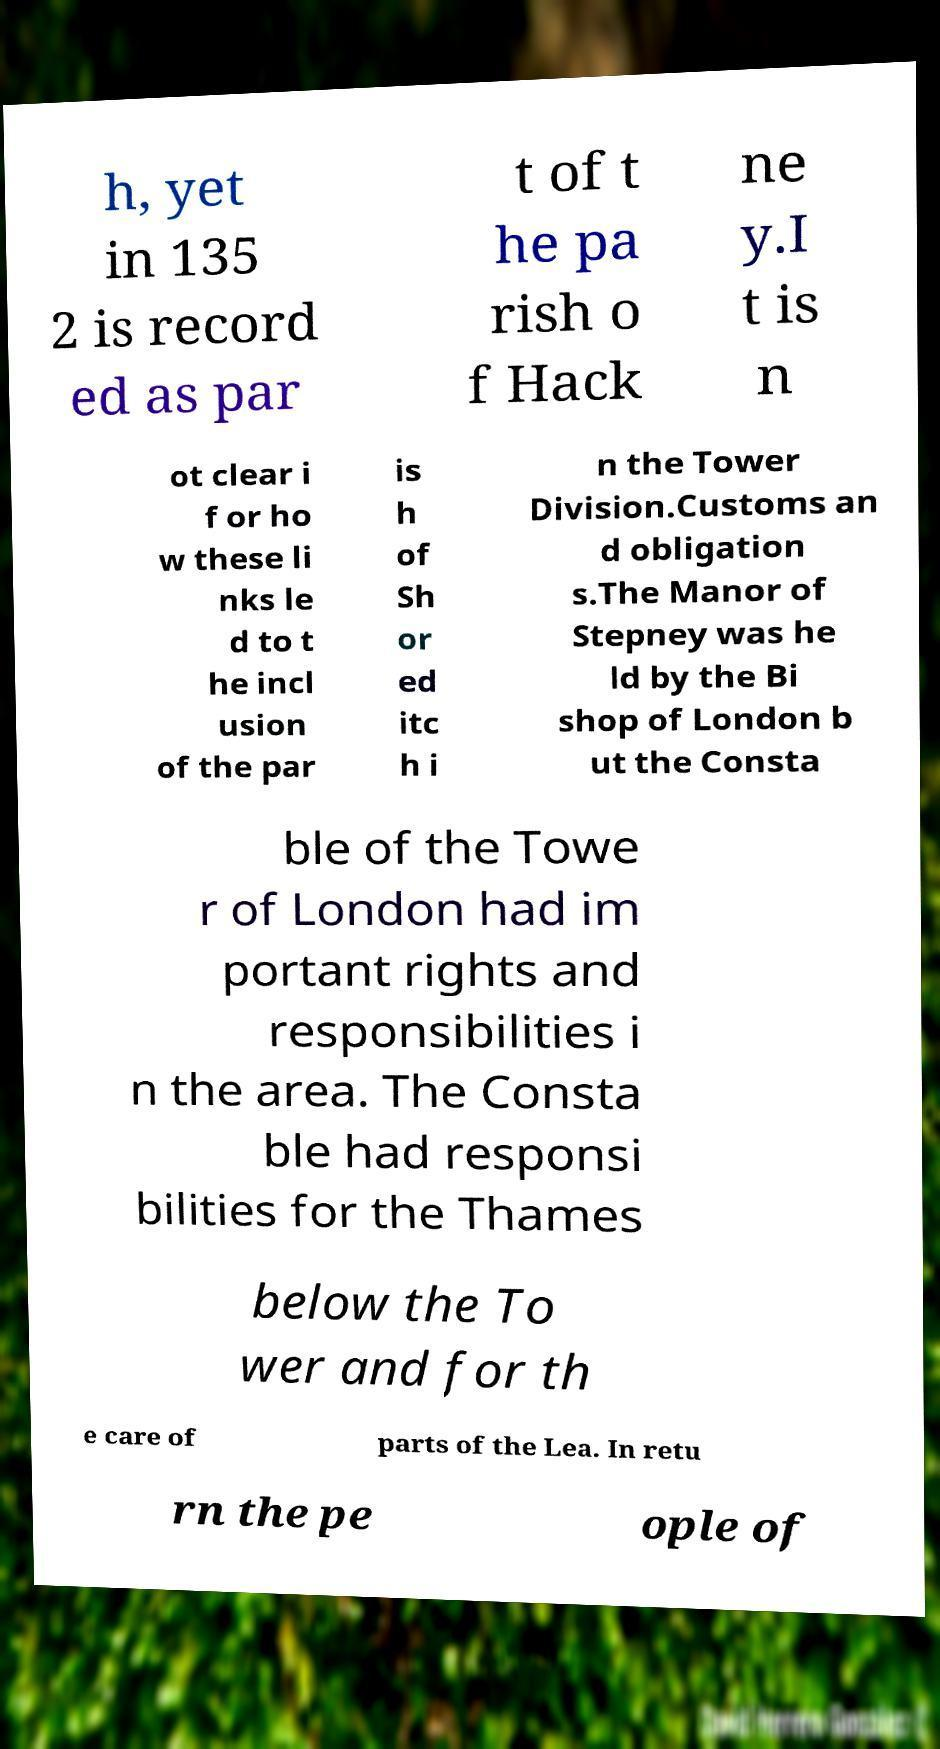Can you read and provide the text displayed in the image?This photo seems to have some interesting text. Can you extract and type it out for me? h, yet in 135 2 is record ed as par t of t he pa rish o f Hack ne y.I t is n ot clear i f or ho w these li nks le d to t he incl usion of the par is h of Sh or ed itc h i n the Tower Division.Customs an d obligation s.The Manor of Stepney was he ld by the Bi shop of London b ut the Consta ble of the Towe r of London had im portant rights and responsibilities i n the area. The Consta ble had responsi bilities for the Thames below the To wer and for th e care of parts of the Lea. In retu rn the pe ople of 